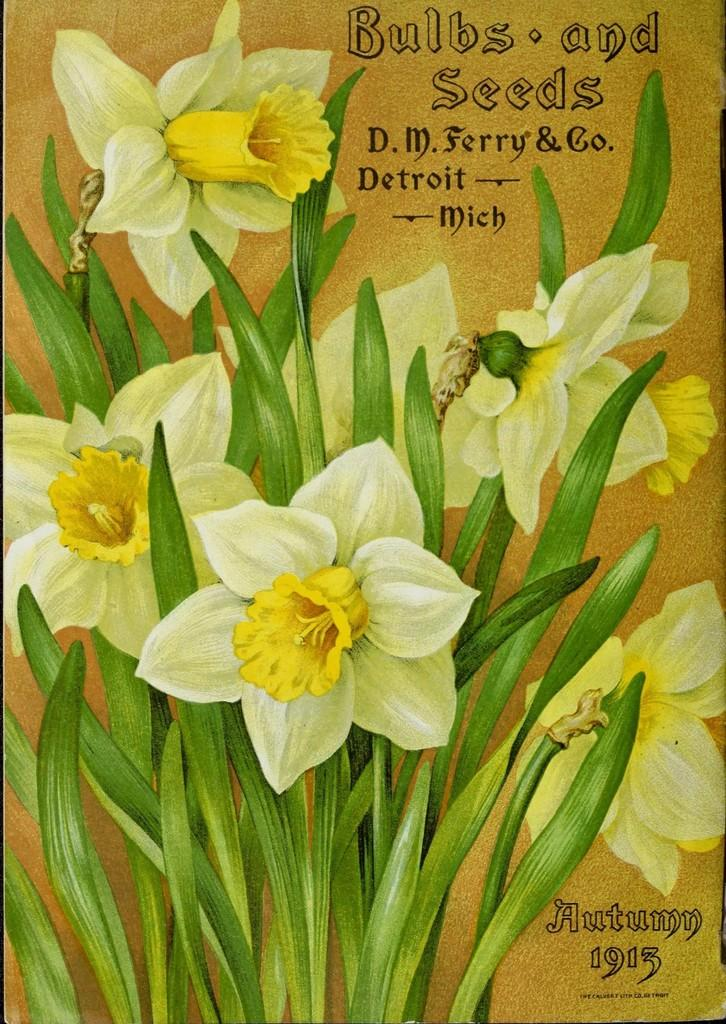What is featured in the image? There is a poster in the image. What can be seen on the poster? The poster contains images of plants with flowers. Is there any text on the poster? Yes, there is text on the poster. How many turkeys are depicted on the poster? There are no turkeys depicted on the poster; it features images of plants with flowers. What type of pizzas are shown on the poster? There are no pizzas present on the poster; it features images of plants with flowers and text. 